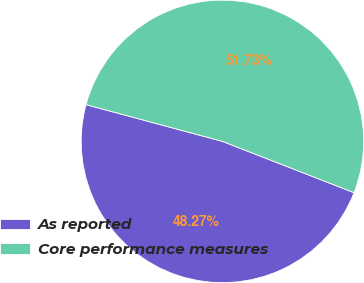Convert chart. <chart><loc_0><loc_0><loc_500><loc_500><pie_chart><fcel>As reported<fcel>Core performance measures<nl><fcel>48.27%<fcel>51.73%<nl></chart> 